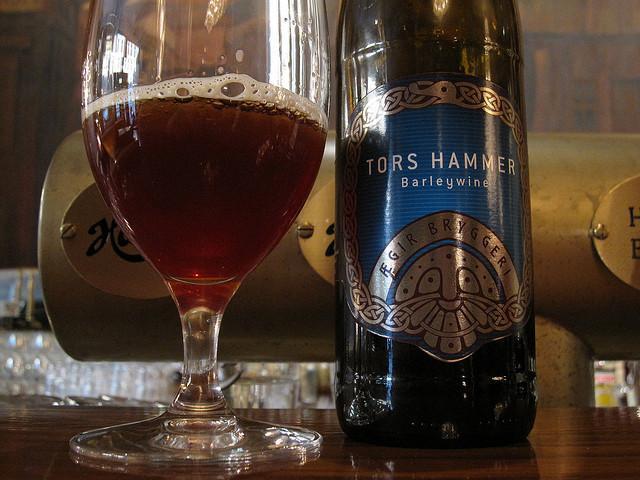The bottle is related to what group of people?
Select the accurate answer and provide justification: `Answer: choice
Rationale: srationale.`
Options: Pharaohs, samurai, roman legionnaires, vikings. Answer: vikings.
Rationale: The first name tor refers to the norse god thor. 